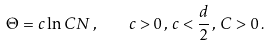Convert formula to latex. <formula><loc_0><loc_0><loc_500><loc_500>\Theta = c \ln C N \, , \quad c > 0 \, , \, c < \frac { d } { 2 } \, , \, C > 0 \, .</formula> 